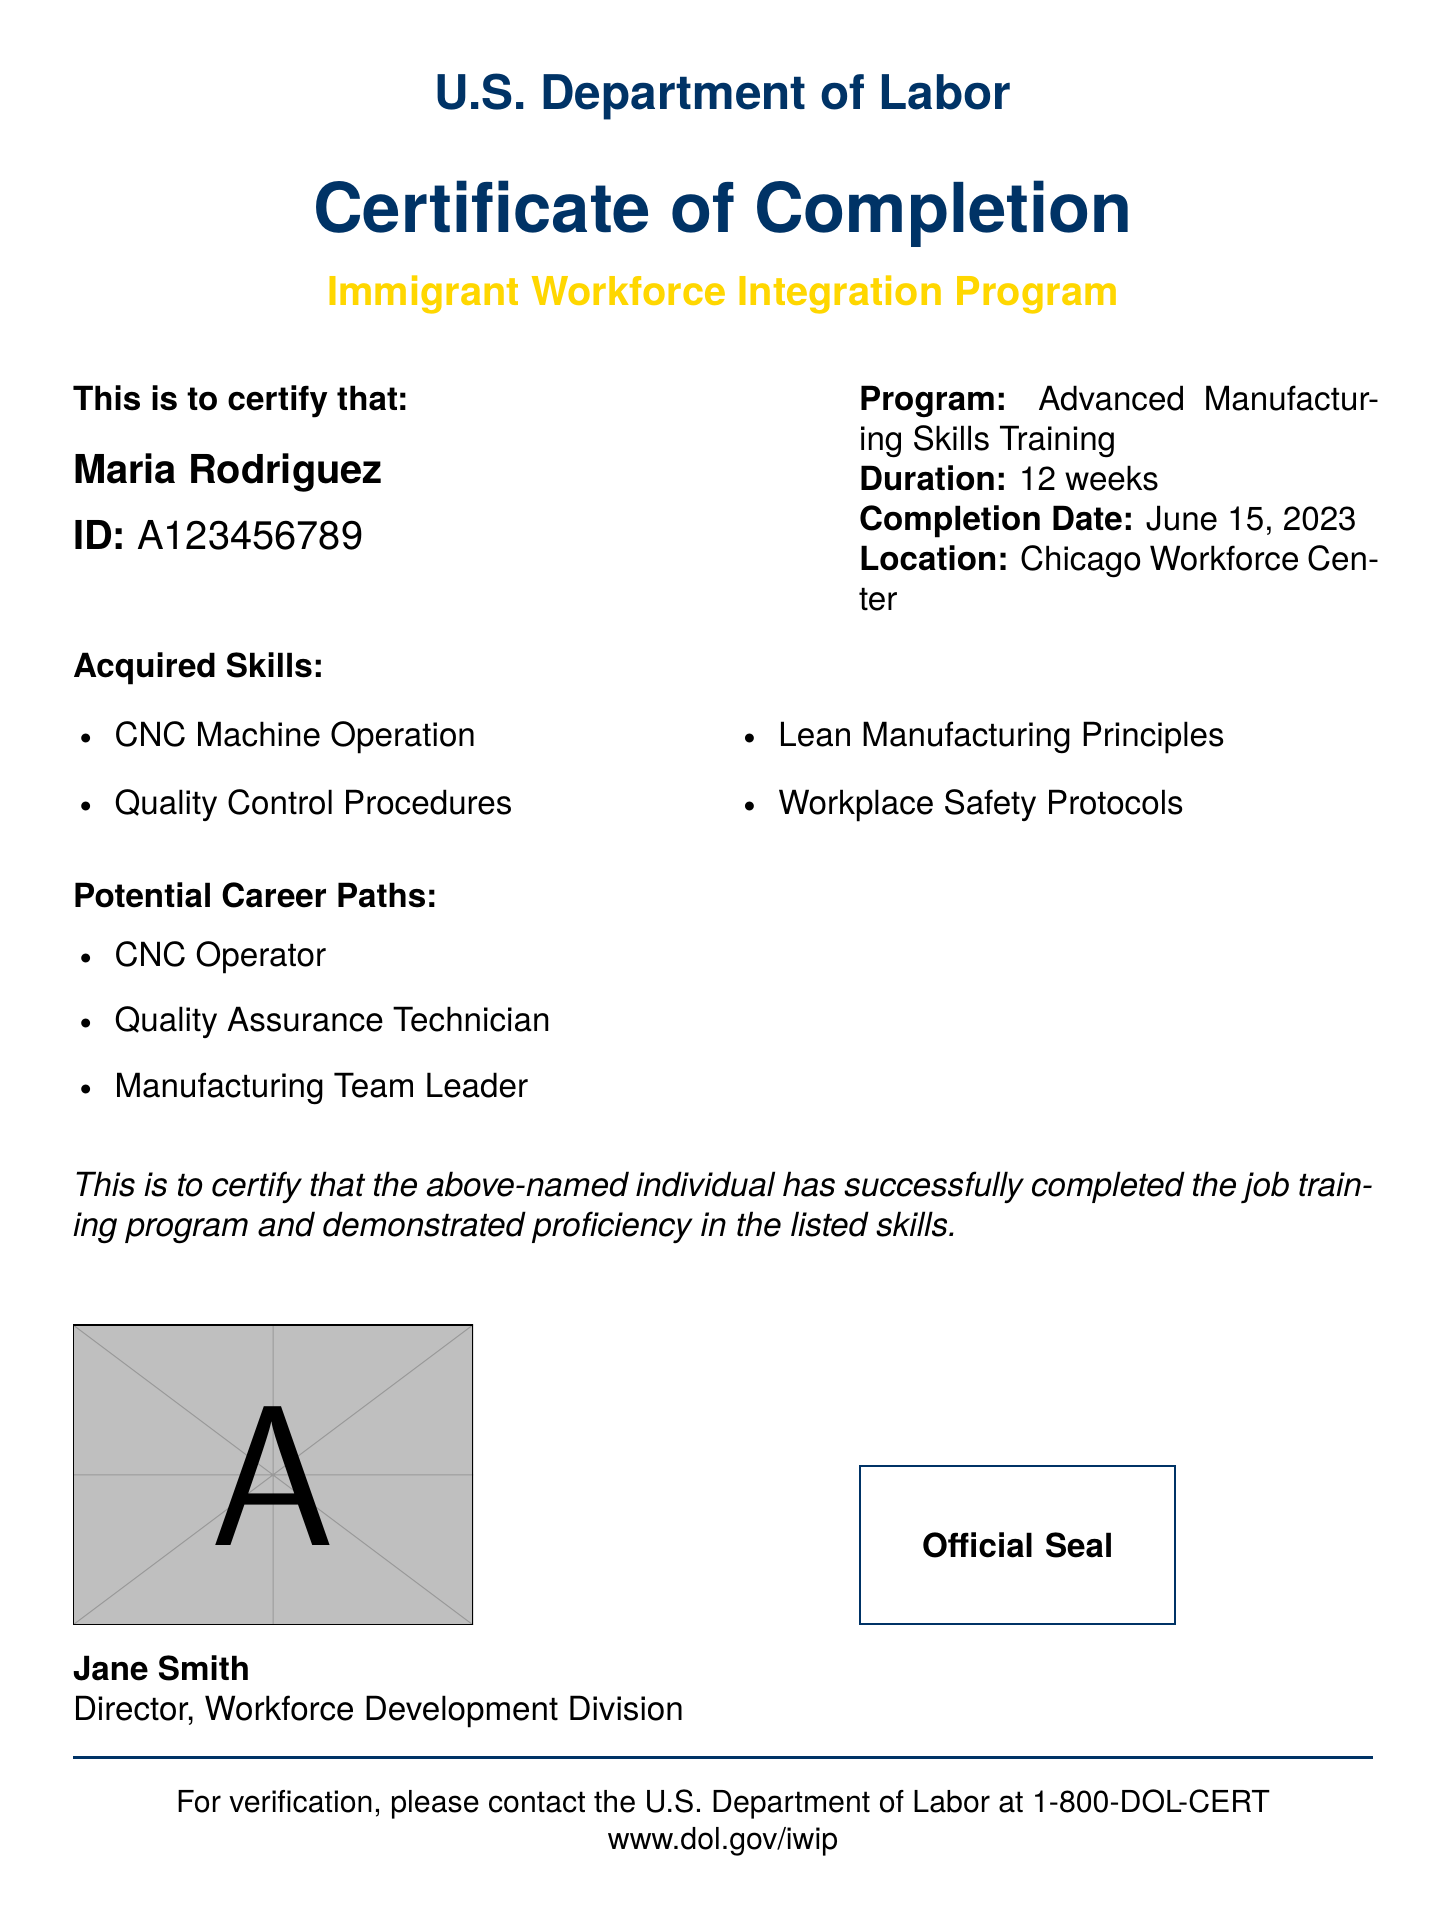What is the name of the program? The program name is listed in the document under the program information section.
Answer: Advanced Manufacturing Skills Training What is the duration of the training program? The document specifies the duration of the program clearly.
Answer: 12 weeks Who is the recipient of the certificate? The certificate mentions the name of the individual who completed the program.
Answer: Maria Rodriguez What skills were acquired during the training? The document lists the skills learned during the program in a dedicated section.
Answer: CNC Machine Operation, Quality Control Procedures, Lean Manufacturing Principles, Workplace Safety Protocols What is the completion date of the program? The completion date is highlighted in the program details.
Answer: June 15, 2023 What potential career path is related to quality assurance? The document mentions career paths associated with the skills learned.
Answer: Quality Assurance Technician Who signed the certificate? The document indicates the name of the person who signed the certificate.
Answer: Jane Smith What is the official contact number for verification? The document provides a specific contact number for verification purposes.
Answer: 1-800-DOL-CERT 